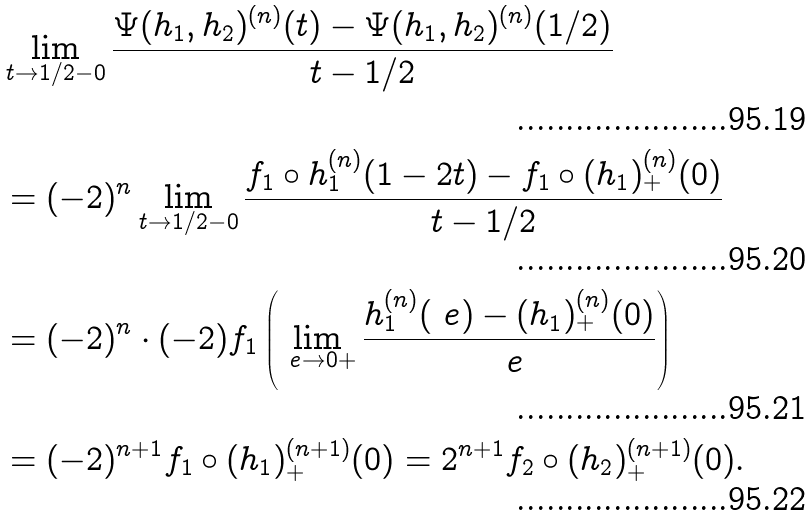Convert formula to latex. <formula><loc_0><loc_0><loc_500><loc_500>& \lim _ { t \to 1 / 2 - 0 } \frac { \Psi ( h _ { 1 } , h _ { 2 } ) ^ { ( n ) } ( t ) - \Psi ( h _ { 1 } , h _ { 2 } ) ^ { ( n ) } ( 1 / 2 ) } { t - 1 / 2 } \\ & = ( - 2 ) ^ { n } \lim _ { t \to 1 / 2 - 0 } \frac { f _ { 1 } \circ h _ { 1 } ^ { ( n ) } ( 1 - 2 t ) - f _ { 1 } \circ ( h _ { 1 } ) _ { + } ^ { ( n ) } ( 0 ) } { t - 1 / 2 } \\ & = ( - 2 ) ^ { n } \cdot ( - 2 ) f _ { 1 } \left ( \lim _ { \ e \to 0 + } \frac { h _ { 1 } ^ { ( n ) } ( \ e ) - ( h _ { 1 } ) _ { + } ^ { ( n ) } ( 0 ) } { \ e } \right ) \\ & = ( - 2 ) ^ { n + 1 } f _ { 1 } \circ ( h _ { 1 } ) _ { + } ^ { ( n + 1 ) } ( 0 ) = 2 ^ { n + 1 } f _ { 2 } \circ ( h _ { 2 } ) _ { + } ^ { ( n + 1 ) } ( 0 ) .</formula> 